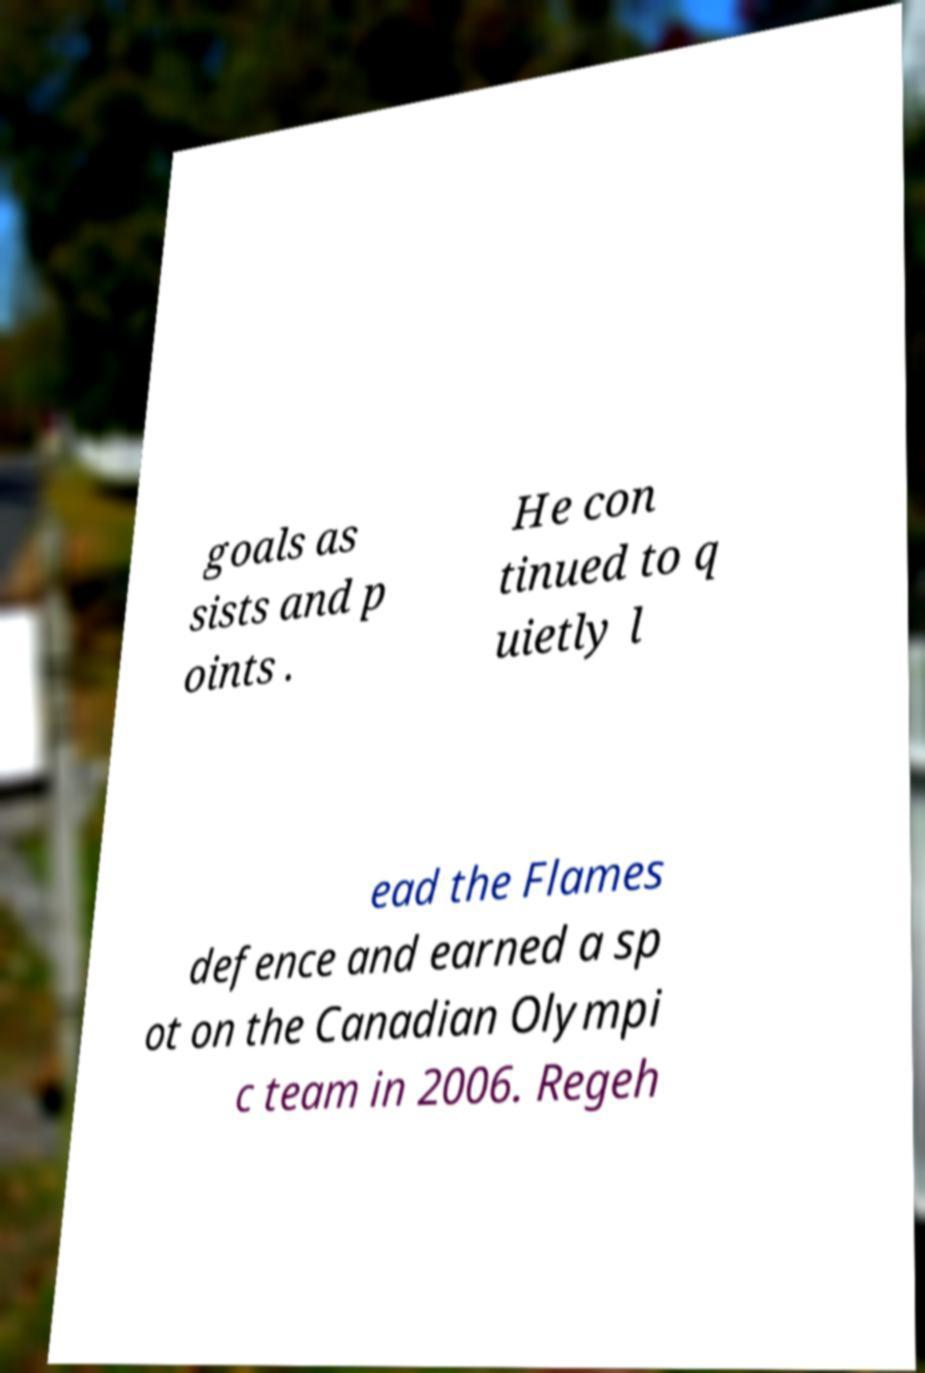Can you accurately transcribe the text from the provided image for me? goals as sists and p oints . He con tinued to q uietly l ead the Flames defence and earned a sp ot on the Canadian Olympi c team in 2006. Regeh 